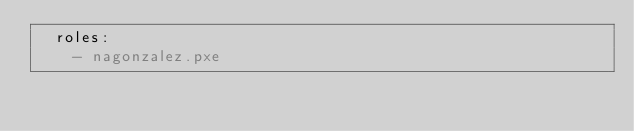Convert code to text. <code><loc_0><loc_0><loc_500><loc_500><_YAML_>  roles:
    - nagonzalez.pxe
</code> 